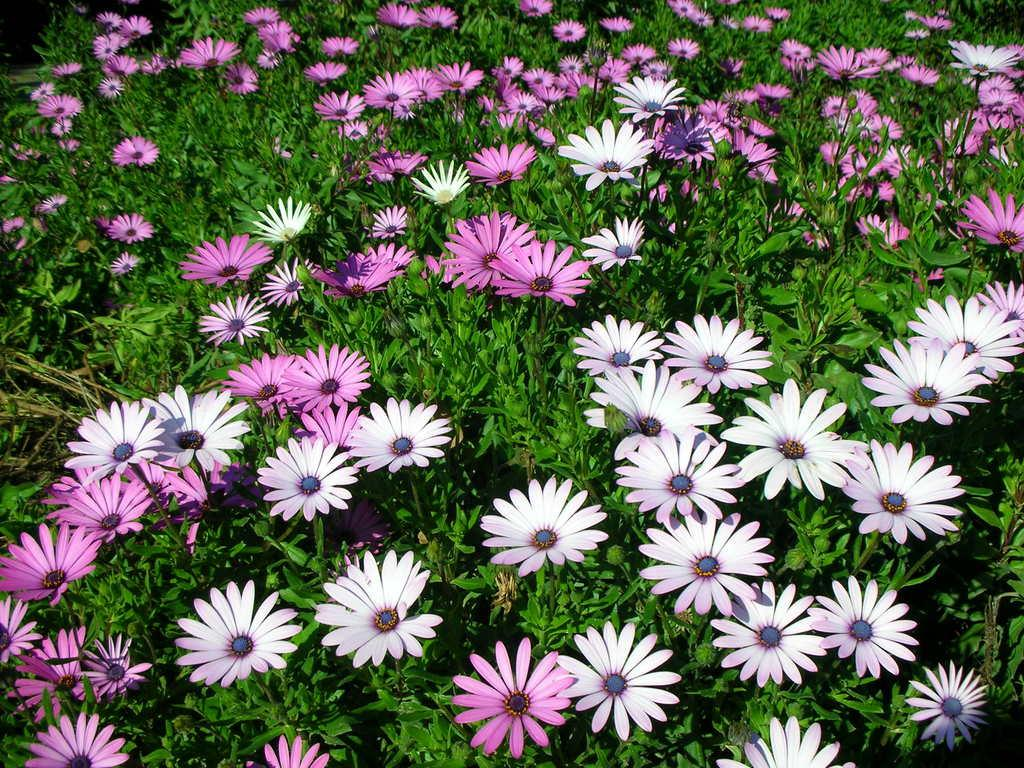What types of living organisms can be seen in the image? Plants and flowers are visible in the image. Can you describe the flowers in the image? The flowers in the image are part of the plants and add color and beauty to the scene. What type of lunch is being served in the image? There is no lunch present in the image; it features plants and flowers. What kind of discussion is taking place in the image? There is no discussion taking place in the image; it features plants and flowers. 